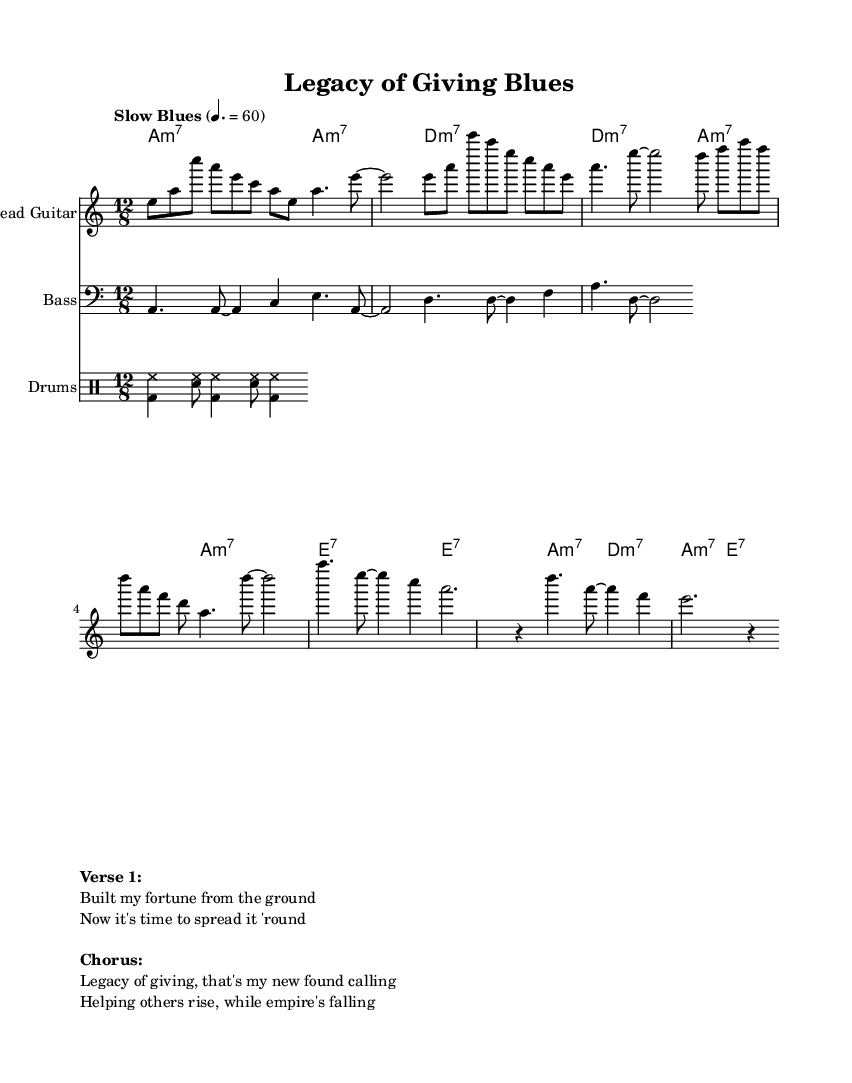What is the key signature of this music? The key signature is indicated by the "a" in the global setup, which denotes A minor. A minor has no sharps or flats.
Answer: A minor What is the time signature of this music? The time signature is shown in the global section as "12/8". This means there are 12 eighth notes per measure, typical for a slow groove in blues music.
Answer: 12/8 What is the tempo marking for this piece? The tempo marking is set to "Slow Blues" at a quarter note equals 60 beats per minute. This reflects the relaxed rhythm characteristic of blues music.
Answer: Slow Blues 4. = 60 How many bars are in the lead guitar part before the first rest? The lead guitar part consists of four bars before the first rest appears at the end of the second measure. By counting the measures, it confirms that there are four bars.
Answer: 4 What chords are used in the chorus? The chords for the chorus, as shown in the harmonies section, are A minor 7 and E7. The structure of the chorus reflects the traditional blues format of the genre.
Answer: A minor 7, E7 What is the main theme expressed in the lyrics? The lyrics communicate the theme of generosity and the legacy of charitable giving, emphasizing helping others and philanthropy as a driving purpose.
Answer: Legacy of giving How does the drum pattern contribute to the electric blues genre? The drum pattern outlines a basic rock rhythm with bass and snare, maintaining a steady, laid-back groove essential for blues, allowing the solo instruments to shine.
Answer: Steady, laid-back groove 